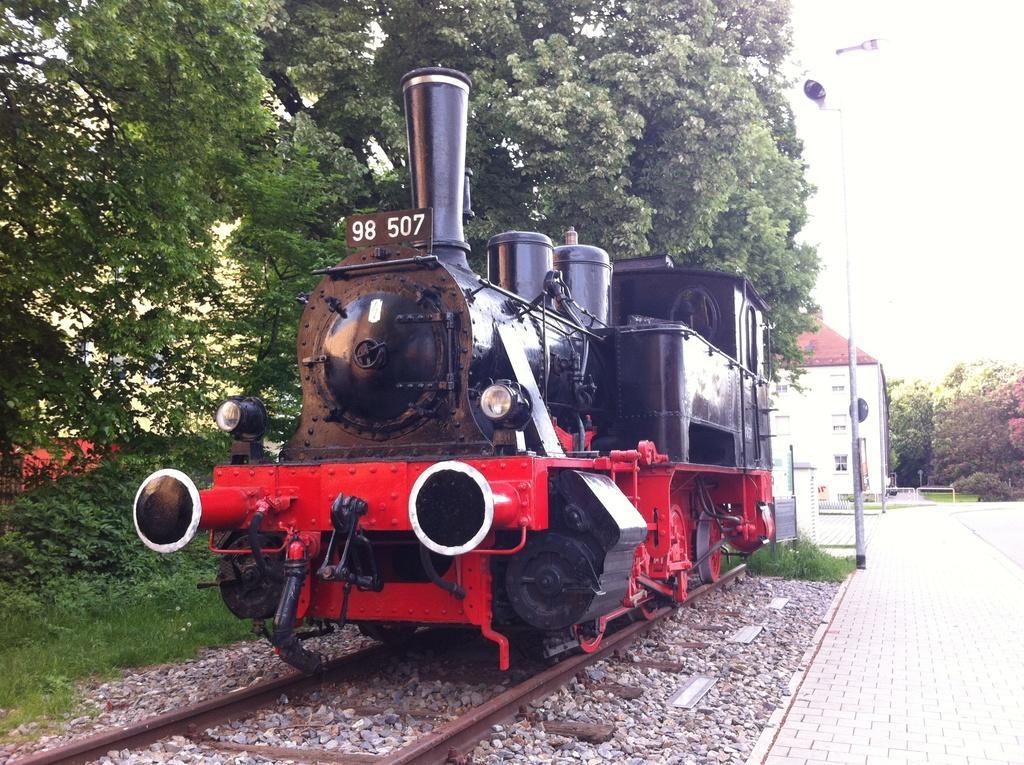In one or two sentences, can you explain what this image depicts? There is a black and red color engine on a railway track. On the railway track there are stones. On the train something is written. In the background there are trees. Also there is a camera with a pole. In the back there is a building. Also there are trees in the background. 